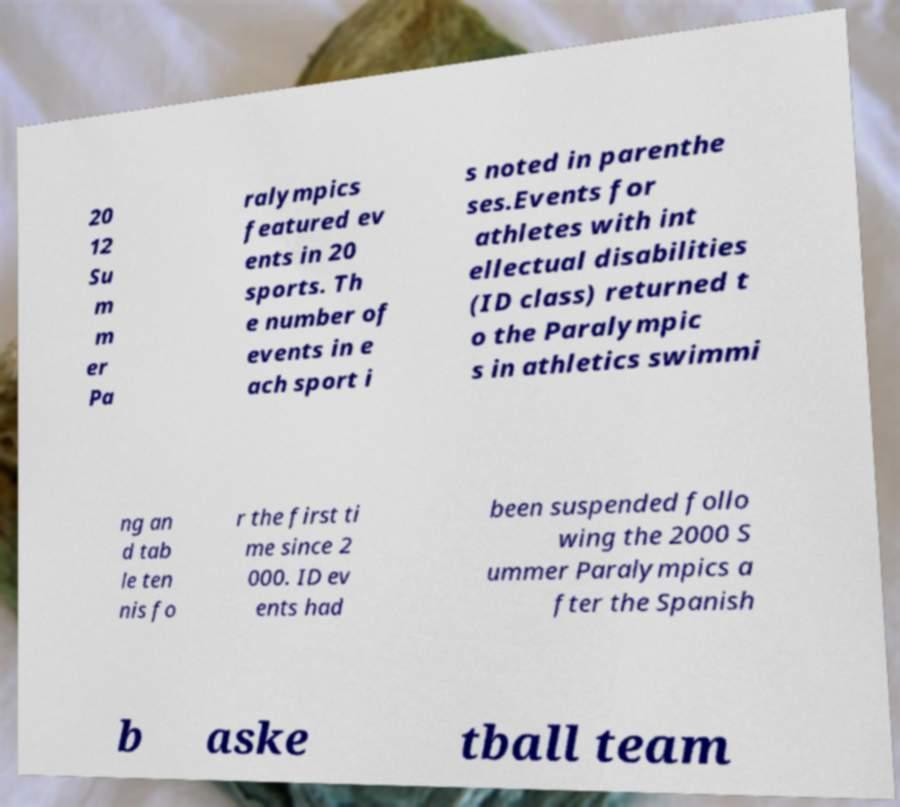There's text embedded in this image that I need extracted. Can you transcribe it verbatim? 20 12 Su m m er Pa ralympics featured ev ents in 20 sports. Th e number of events in e ach sport i s noted in parenthe ses.Events for athletes with int ellectual disabilities (ID class) returned t o the Paralympic s in athletics swimmi ng an d tab le ten nis fo r the first ti me since 2 000. ID ev ents had been suspended follo wing the 2000 S ummer Paralympics a fter the Spanish b aske tball team 